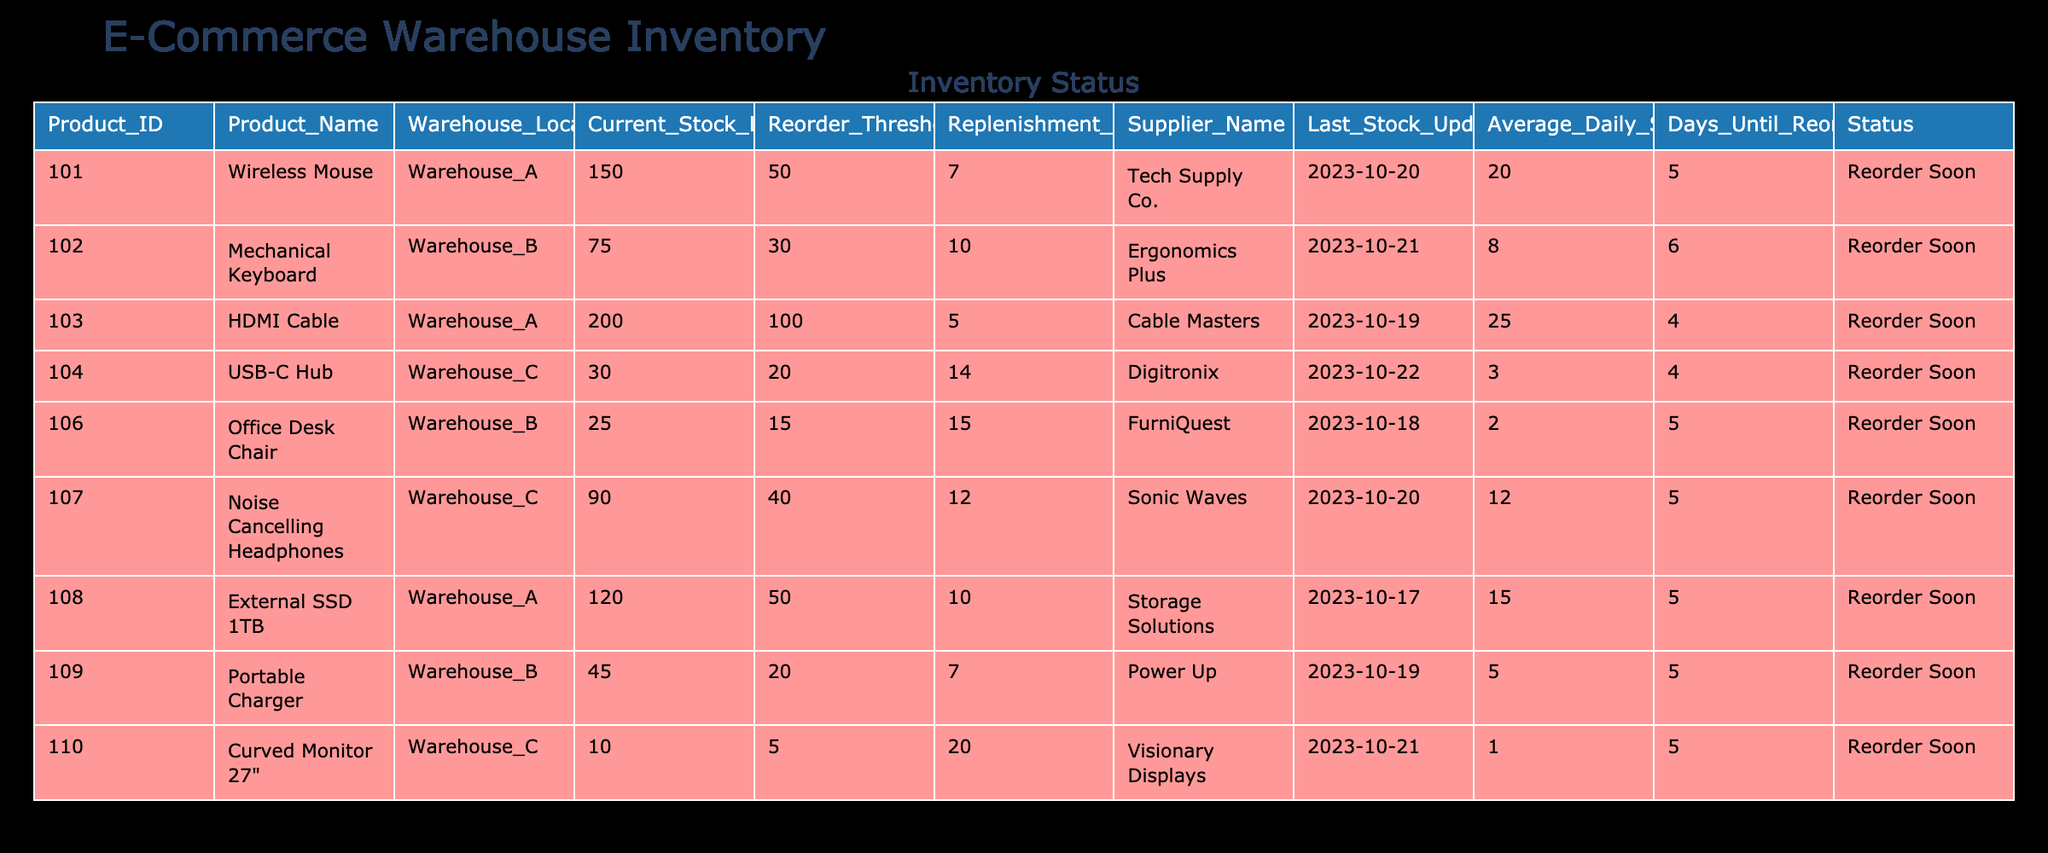What is the current stock level of the Mechanical Keyboard? According to the table, the current stock level for the Mechanical Keyboard (Product ID 102) is directly listed under the "Current Stock Level" column. It shows a value of 75.
Answer: 75 How many days until the USB-C Hub needs to be reordered? The columns provide the current stock level (30), reorder threshold (20), and average daily sales (3), allowing us to calculate the days until reorder. The formula is (Current Stock Level - Reorder Threshold) / Average Daily Sales = (30 - 20) / 3 = 10 days.
Answer: 10 Is the Office Desk Chair at a safe stock level? The current stock level of the Office Desk Chair is 25, and the reorder threshold is 15. This means that the stock is above the reorder threshold; therefore, it is at a safe level.
Answer: Yes Which product has the longest replenishment timeline? The replenishment timelines for each product are compared: Wireless Mouse (7 days), Mechanical Keyboard (10 days), HDMI Cable (5 days), USB-C Hub (14 days), Office Desk Chair (15 days), Noise Cancelling Headphones (12 days), External SSD 1TB (10 days), Portable Charger (7 days), Curved Monitor 27" (20 days). The Curved Monitor has the longest replenishment timeline at 20 days.
Answer: Curved Monitor 27" If the average daily sales of the HDMI Cable doubled, how many days until it reaches the reorder threshold? The current stock level is 200, the reorder threshold is 100, and the new average daily sales (doubled from 25) would be 50. Using the formula: (Current Stock Level - Reorder Threshold) / Average Daily Sales = (200 - 100) / 50 = 2 days.
Answer: 2 How many products are currently at risk of being reordered soon? By checking the "Status" column, we identify products marked "Reorder Soon." These are the USB-C Hub, Office Desk Chair, Portable Charger, and Curved Monitor. This gives us a total of 4 products at risk.
Answer: 4 What is the total average daily sales for all products listed? The daily sales for each product are summed up: 20 + 8 + 25 + 3 + 2 + 12 + 15 + 5 + 1 = 91. With 9 products, the average is 91/9 = 10.11 (rounded to two decimal places).
Answer: 10.11 Which supplier provides the most products in the table? By counting the occurrences of each supplier in the "Supplier Name" column, we have: Tech Supply Co. (1), Ergonomics Plus (1), Cable Masters (1), Digitronix (1), FurniQuest (1), Sonic Waves (1), Storage Solutions (1), Power Up (1), and Visionary Displays (1). Each supplier has 1 product, leading to no clear supplier with the most products.
Answer: None If the stock level for the Noise Cancelling Headphones were to drop to the reorder threshold, what would be the new stock level? The reorder threshold for the Noise Cancelling Headphones is 40. If the stock level dropped to this threshold, it would simply be 40; thus, there would be no calculations necessary.
Answer: 40 